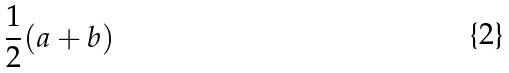<formula> <loc_0><loc_0><loc_500><loc_500>\frac { 1 } { 2 } ( a + b )</formula> 